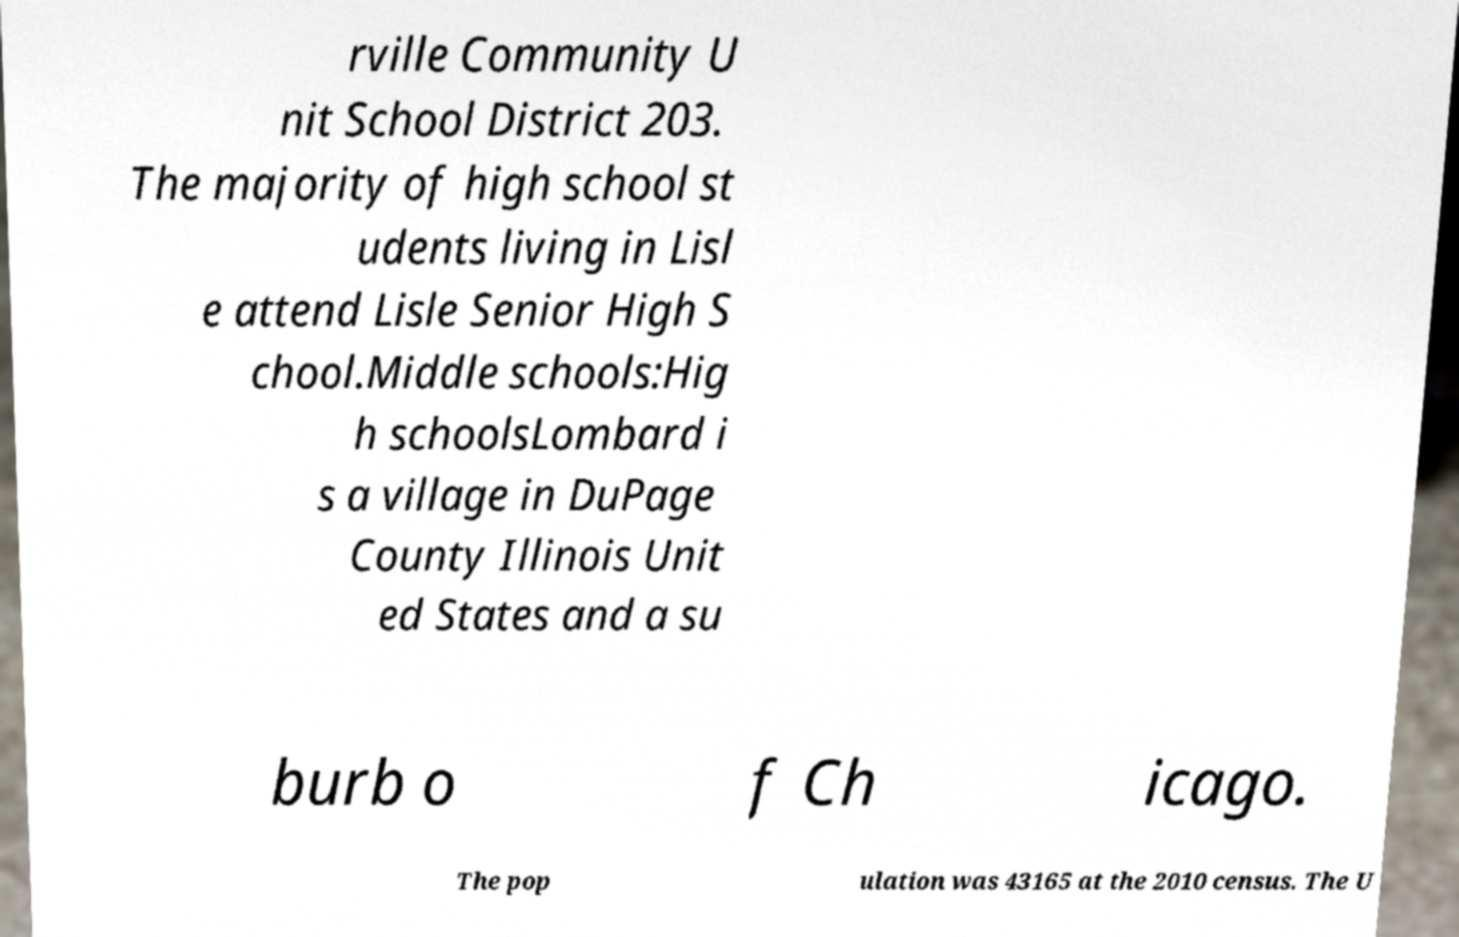I need the written content from this picture converted into text. Can you do that? rville Community U nit School District 203. The majority of high school st udents living in Lisl e attend Lisle Senior High S chool.Middle schools:Hig h schoolsLombard i s a village in DuPage County Illinois Unit ed States and a su burb o f Ch icago. The pop ulation was 43165 at the 2010 census. The U 